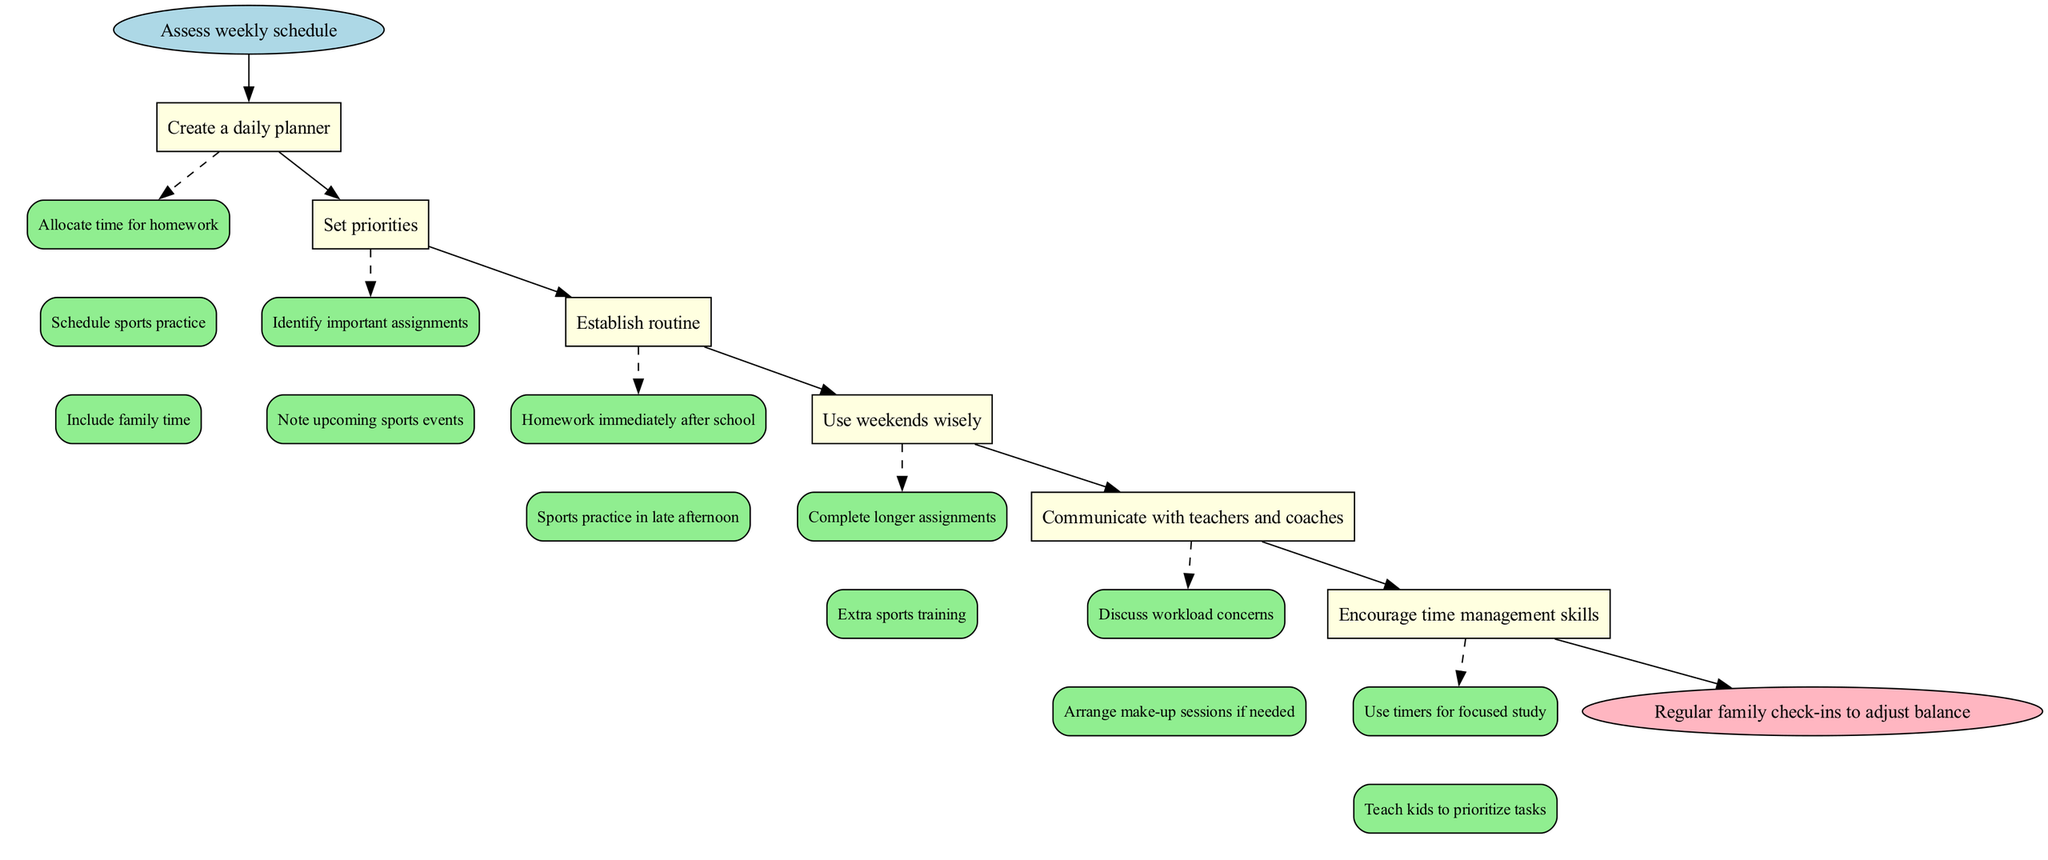What is the first step in the diagram? The diagram begins with the "Assess weekly schedule" step, which indicates the starting point of the process. This step is represented at the top and is linked to the first instructional step.
Answer: Assess weekly schedule How many main steps are outlined in the diagram? There are six main steps listed in the diagram before moving to the end. Each step corresponds to a rectangular node in the flowchart that outlines a specific action.
Answer: 6 What is the last node in the diagram? The last node is an "end" node labeled "Regular family check-ins to adjust balance." This indicates the completion of the instruction flow.
Answer: Regular family check-ins to adjust balance Which step includes discussing workload concerns? The step "Communicate with teachers and coaches" includes details about discussing workload concerns with teachers, indicating an important interaction to manage schedules effectively.
Answer: Communicate with teachers and coaches What are the two activities recommended for using weekends wisely? The two activities suggested are "Complete longer assignments" and "Extra sports training," highlighting important time management activities for weekends.
Answer: Complete longer assignments, Extra sports training What is the relationship between the step "Set priorities" and "Establish routine"? "Set priorities" is a step that precedes "Establish routine" in the flowchart, indicating that determining priorities must occur before establishing a daily routine for homework and sports practice.
Answer: Set priorities precedes Establish routine Which step emphasizes the importance of communication? The step "Communicate with teachers and coaches" is focused on emphasizing the need for effective communication regarding schedule and workload issues.
Answer: Communicate with teachers and coaches What action should be taken immediately after school according to the routine? The routine suggests doing "Homework immediately after school," providing a structured approach to managing after-school activities.
Answer: Homework immediately after school What does the step "Encourage time management skills" highlight in terms of technique? This step highlights techniques such as "Use timers for focused study" and "Teach kids to prioritize tasks," indicating a focus on developing essential life skills related to managing time effectively.
Answer: Use timers for focused study, Teach kids to prioritize tasks 